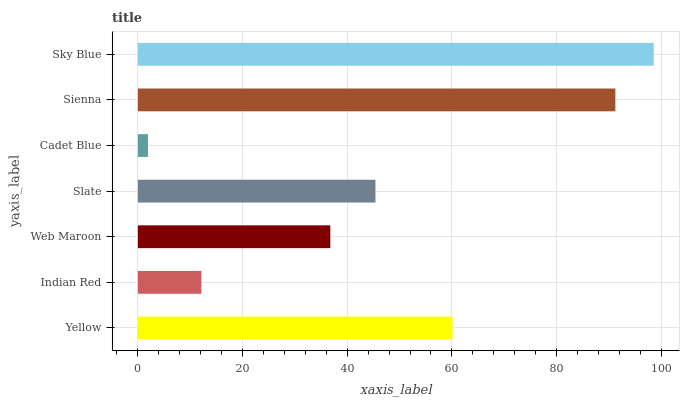Is Cadet Blue the minimum?
Answer yes or no. Yes. Is Sky Blue the maximum?
Answer yes or no. Yes. Is Indian Red the minimum?
Answer yes or no. No. Is Indian Red the maximum?
Answer yes or no. No. Is Yellow greater than Indian Red?
Answer yes or no. Yes. Is Indian Red less than Yellow?
Answer yes or no. Yes. Is Indian Red greater than Yellow?
Answer yes or no. No. Is Yellow less than Indian Red?
Answer yes or no. No. Is Slate the high median?
Answer yes or no. Yes. Is Slate the low median?
Answer yes or no. Yes. Is Web Maroon the high median?
Answer yes or no. No. Is Sky Blue the low median?
Answer yes or no. No. 